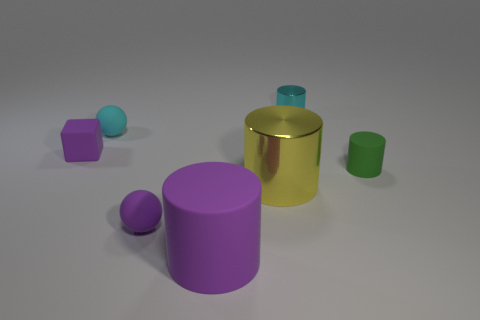What number of green things are big metal things or matte cylinders?
Your response must be concise. 1. Is the block made of the same material as the sphere that is to the right of the cyan sphere?
Your answer should be compact. Yes. There is a yellow metallic object that is the same shape as the green rubber thing; what size is it?
Ensure brevity in your answer.  Large. What is the small cyan cylinder made of?
Offer a very short reply. Metal. There is a object that is left of the matte ball behind the big thing behind the large purple rubber object; what is its material?
Your answer should be very brief. Rubber. Does the cylinder in front of the small purple rubber ball have the same size as the metal cylinder that is on the right side of the large shiny object?
Your answer should be compact. No. How many other things are there of the same material as the big yellow cylinder?
Give a very brief answer. 1. How many matte objects are either small cubes or small cylinders?
Make the answer very short. 2. Is the number of small purple objects less than the number of small red matte cylinders?
Make the answer very short. No. Do the purple rubber cylinder and the shiny thing left of the small cyan cylinder have the same size?
Your answer should be very brief. Yes. 